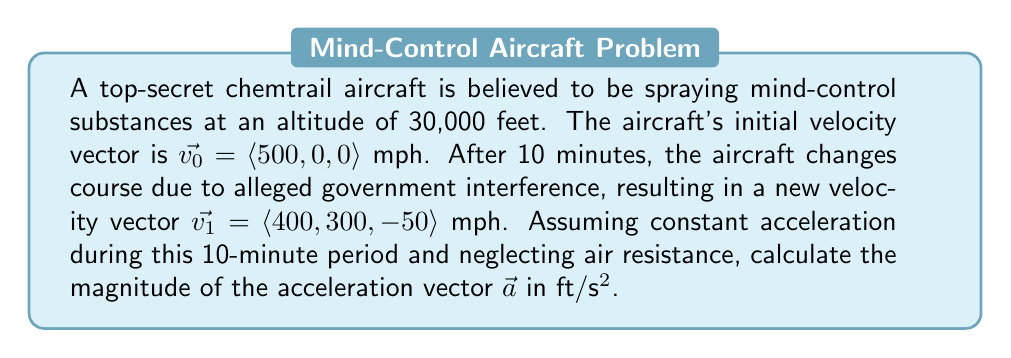Help me with this question. To solve this problem, we'll follow these steps:

1) Convert the given velocities from mph to ft/s:
   $\vec{v_0} = \langle 500, 0, 0 \rangle$ mph = $\langle 733.33, 0, 0 \rangle$ ft/s
   $\vec{v_1} = \langle 400, 300, -50 \rangle$ mph = $\langle 586.67, 440, -73.33 \rangle$ ft/s

2) Calculate the change in velocity:
   $\Delta \vec{v} = \vec{v_1} - \vec{v_0} = \langle 586.67 - 733.33, 440 - 0, -73.33 - 0 \rangle$
   $\Delta \vec{v} = \langle -146.66, 440, -73.33 \rangle$ ft/s

3) Calculate the time interval in seconds:
   $\Delta t = 10$ minutes = 600 seconds

4) Use the acceleration formula:
   $\vec{a} = \frac{\Delta \vec{v}}{\Delta t}$

5) Substitute the values:
   $\vec{a} = \frac{\langle -146.66, 440, -73.33 \rangle}{600}$ ft/s²
   $\vec{a} = \langle -0.2444, 0.7333, -0.1222 \rangle$ ft/s²

6) Calculate the magnitude of the acceleration vector:
   $|\vec{a}| = \sqrt{(-0.2444)^2 + (0.7333)^2 + (-0.1222)^2}$
   $|\vec{a}| = \sqrt{0.0597 + 0.5377 + 0.0149}$
   $|\vec{a}| = \sqrt{0.6123}$
   $|\vec{a}| \approx 0.7824$ ft/s²

Therefore, the magnitude of the acceleration vector is approximately 0.7824 ft/s².
Answer: $|\vec{a}| \approx 0.7824$ ft/s² 